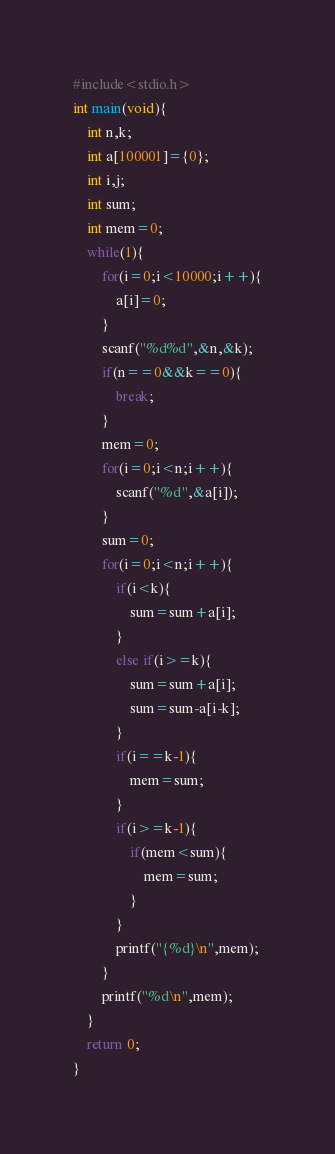Convert code to text. <code><loc_0><loc_0><loc_500><loc_500><_C_>#include<stdio.h>
int main(void){
    int n,k;
    int a[100001]={0};
    int i,j;
    int sum;
    int mem=0;
    while(1){
        for(i=0;i<10000;i++){
            a[i]=0;
        }
        scanf("%d%d",&n,&k);
        if(n==0&&k==0){
            break;
        }
        mem=0;
        for(i=0;i<n;i++){
            scanf("%d",&a[i]);
        }
        sum=0;
        for(i=0;i<n;i++){
            if(i<k){
                sum=sum+a[i];
            }
            else if(i>=k){
                sum=sum+a[i];
                sum=sum-a[i-k];
            }
            if(i==k-1){
                mem=sum;
            }
            if(i>=k-1){
                if(mem<sum){
                    mem=sum;
                }
            }
            printf("{%d}\n",mem);
        }
        printf("%d\n",mem);
    }
    return 0;
}</code> 